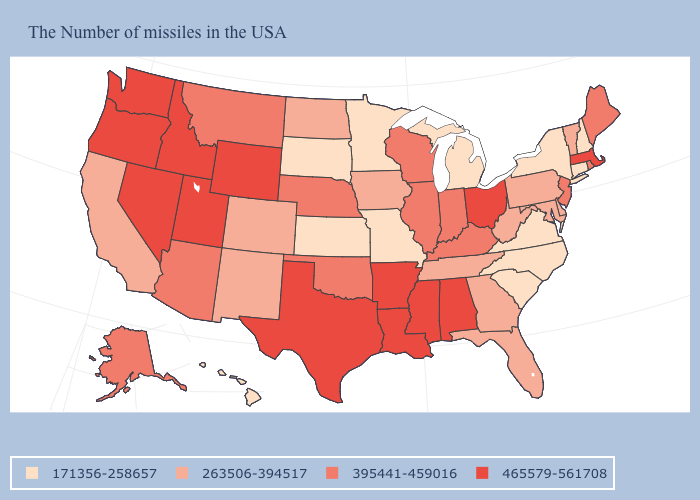Among the states that border South Carolina , which have the lowest value?
Answer briefly. North Carolina. Which states hav the highest value in the MidWest?
Be succinct. Ohio. Does the map have missing data?
Short answer required. No. Is the legend a continuous bar?
Short answer required. No. What is the value of Hawaii?
Be succinct. 171356-258657. Does the map have missing data?
Quick response, please. No. What is the value of Indiana?
Short answer required. 395441-459016. What is the value of Idaho?
Write a very short answer. 465579-561708. Does West Virginia have the highest value in the USA?
Quick response, please. No. What is the value of Idaho?
Concise answer only. 465579-561708. Name the states that have a value in the range 465579-561708?
Quick response, please. Massachusetts, Ohio, Alabama, Mississippi, Louisiana, Arkansas, Texas, Wyoming, Utah, Idaho, Nevada, Washington, Oregon. Does Oregon have the same value as Texas?
Keep it brief. Yes. What is the value of Vermont?
Give a very brief answer. 263506-394517. What is the value of Colorado?
Give a very brief answer. 263506-394517. Which states have the highest value in the USA?
Keep it brief. Massachusetts, Ohio, Alabama, Mississippi, Louisiana, Arkansas, Texas, Wyoming, Utah, Idaho, Nevada, Washington, Oregon. 